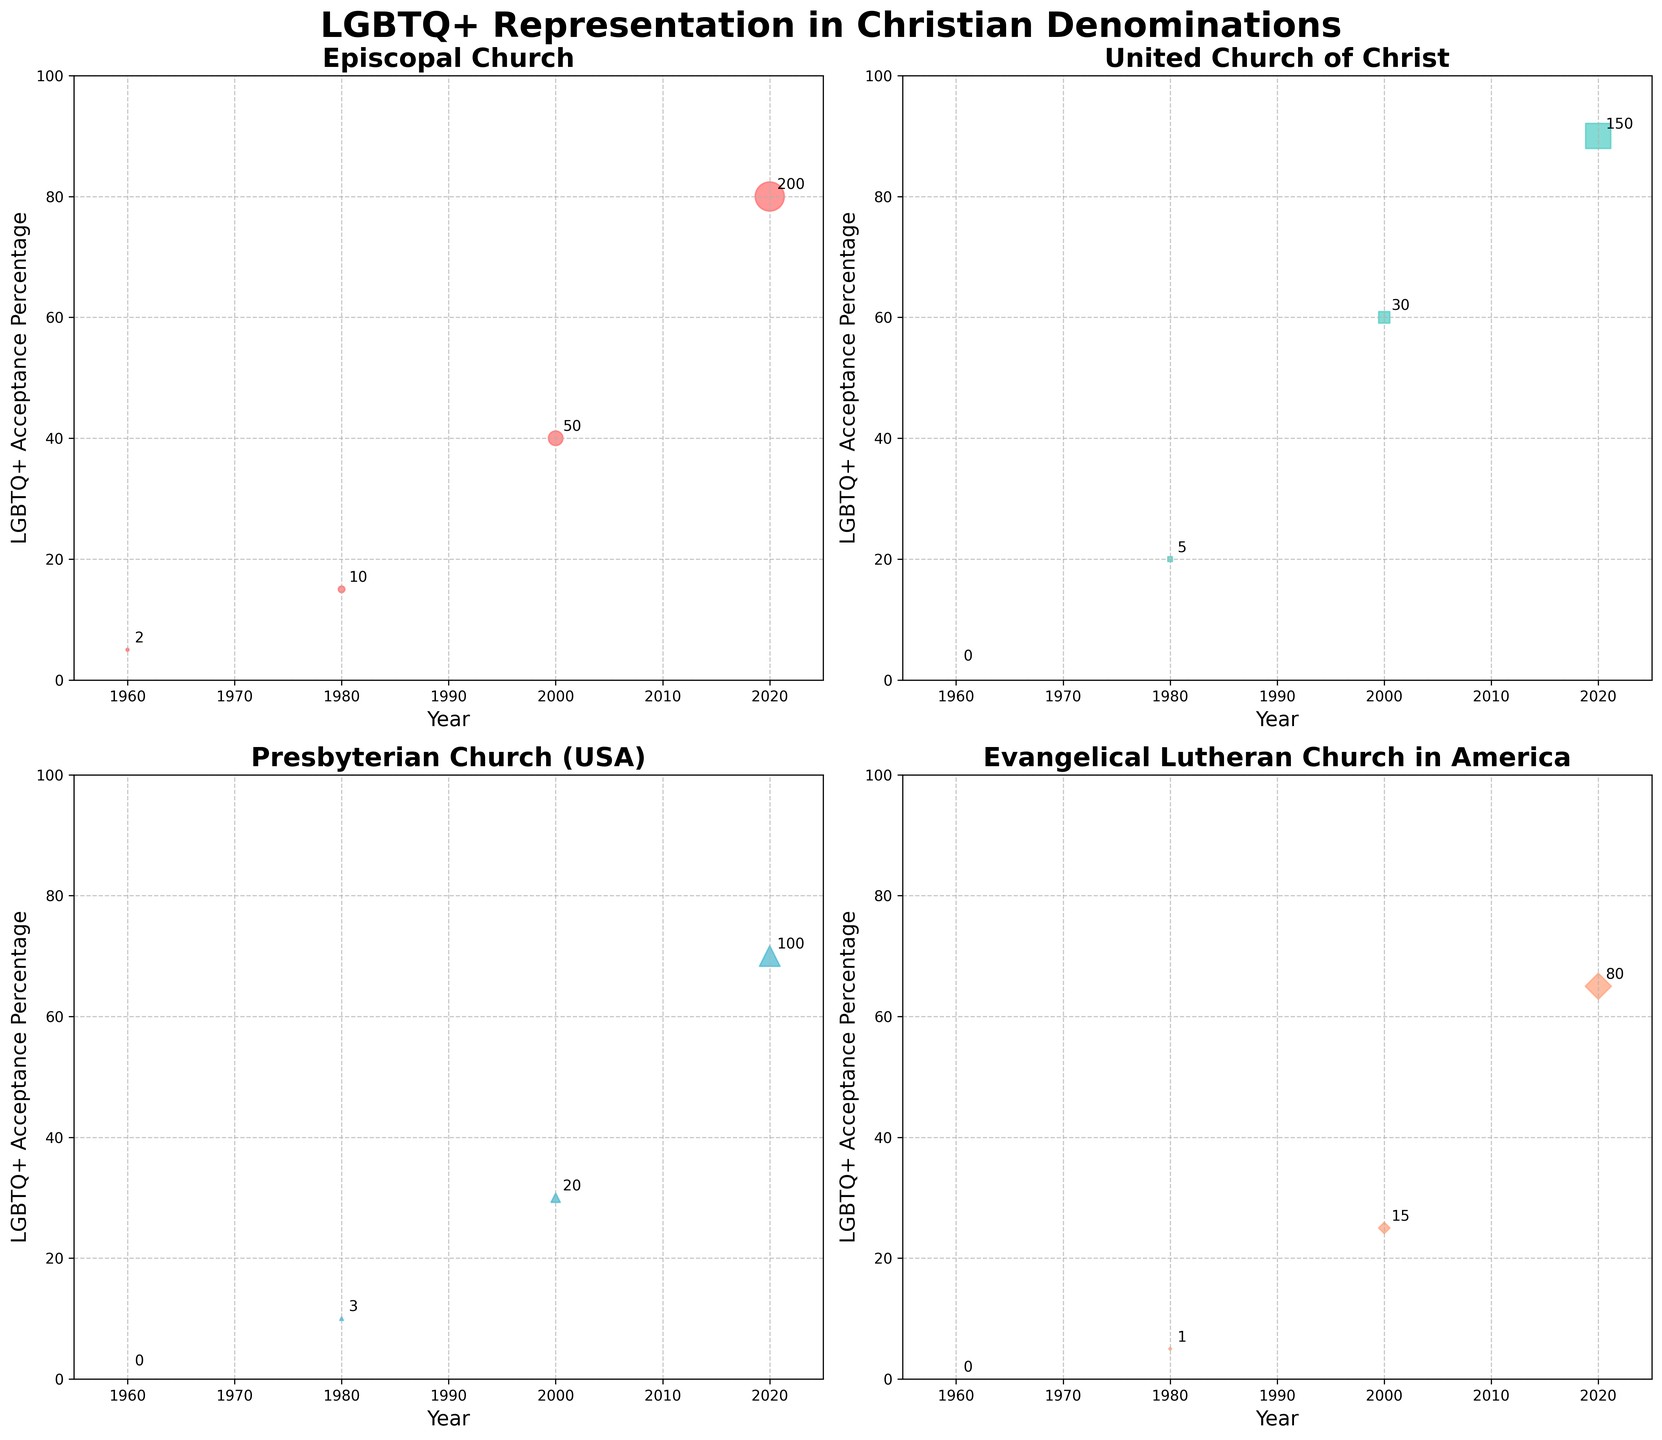What is the title of the figure? The title of the figure is displayed prominently at the top. It reads "LGBTQ+ Representation in Christian Denominations."
Answer: LGBTQ+ Representation in Christian Denominations How many denominations are analyzed in this figure? There are four subplots, one for each denomination, indicating that four denominations are analyzed.
Answer: Four Which denomination showed the highest percentage of LGBTQ+ acceptance in 2020? By looking at all the subplots, the United Church of Christ has a point at 2020 with the highest acceptance percentage, which is 90%.
Answer: United Church of Christ Which denomination had no LGBTQ+ clergy in 1960? In the 1960 data points of each subplot, only the Episcopal Church had LGBTQ+ clergy (2). The other three denominations, namely the United Church of Christ, the Presbyterian Church (USA), and the Evangelical Lutheran Church in America, had zero LGBTQ+ clergy in 1960.
Answer: United Church of Christ, Presbyterian Church (USA), Evangelical Lutheran Church in America Compare the number of LGBTQ+ clergy in the Episcopal Church from 1980 to 2020. What is the difference? The number of LGBTQ+ clergy in the Episcopal Church was 10 in 1980 and 200 in 2020. The difference is 200 - 10 = 190.
Answer: 190 Which denomination had the smallest LGBTQ+ acceptance percentage increase from 1960 to 2020? By comparing all subplots, the smallest increase can be calculated: Episcopal Church (80 - 5 = 75), United Church of Christ (90 - 2 = 88), Presbyterian Church (USA) (70 - 1 = 69), Evangelical Lutheran Church in America (65 - 0 = 65). The denomination with the smallest increase is the Evangelical Lutheran Church in America.
Answer: Evangelical Lutheran Church in America Which denomination had the highest number of LGBTQ+ clergy in 2000? By comparing the 2000 data points from all subplots, the Episcopal Church had 50 LGBTQ+ clergy, United Church of Christ had 30, Presbyterian Church (USA) had 20, and Evangelical Lutheran Church in America had 15. The highest number is 50 in the Episcopal Church.
Answer: Episcopal Church Between 2000 and 2020, which denomination experienced the greatest increase in LGBTQ+ clergy numbers? By calculating the difference in LGBTQ+ clergy between 2000 and 2020 in each denomination: Episcopal Church (200 - 50 = 150), United Church of Christ (150 - 30 = 120), Presbyterian Church (USA) (100 - 20 = 80), Evangelical Lutheran Church in America (80 - 15 = 65). The greatest increase of 150 is in the Episcopal Church.
Answer: Episcopal Church Which denomination had the largest LGBTQ+ clergy representation compared to its LGBTQ+ acceptance percentage in 2020? Looking at the 2020 data points, calculate the ratio of the number of LGBTQ+ clergy to the LGBTQ+ acceptance percentage: Episcopal Church (200/80 = 2.5), United Church of Christ (150/90 = 1.67), Presbyterian Church (USA) (100/70 = 1.43), Evangelical Lutheran Church in America (80/65 = 1.23). The largest ratio is 2.5 in the Episcopal Church.
Answer: Episcopal Church 